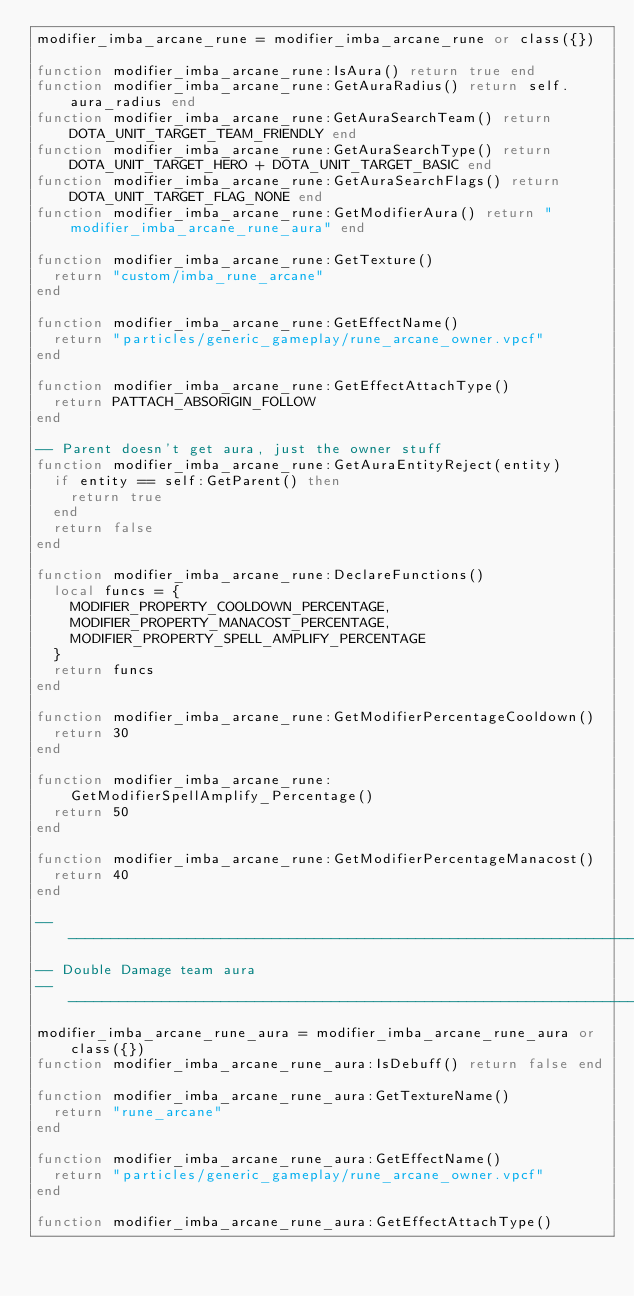<code> <loc_0><loc_0><loc_500><loc_500><_Lua_>modifier_imba_arcane_rune = modifier_imba_arcane_rune or class({})

function modifier_imba_arcane_rune:IsAura() return true end
function modifier_imba_arcane_rune:GetAuraRadius() return self.aura_radius end
function modifier_imba_arcane_rune:GetAuraSearchTeam() return DOTA_UNIT_TARGET_TEAM_FRIENDLY end
function modifier_imba_arcane_rune:GetAuraSearchType() return DOTA_UNIT_TARGET_HERO + DOTA_UNIT_TARGET_BASIC end
function modifier_imba_arcane_rune:GetAuraSearchFlags() return DOTA_UNIT_TARGET_FLAG_NONE end
function modifier_imba_arcane_rune:GetModifierAura() return "modifier_imba_arcane_rune_aura" end

function modifier_imba_arcane_rune:GetTexture()
	return "custom/imba_rune_arcane"
end

function modifier_imba_arcane_rune:GetEffectName()
	return "particles/generic_gameplay/rune_arcane_owner.vpcf"
end

function modifier_imba_arcane_rune:GetEffectAttachType()
	return PATTACH_ABSORIGIN_FOLLOW
end

-- Parent doesn't get aura, just the owner stuff
function modifier_imba_arcane_rune:GetAuraEntityReject(entity)
	if entity == self:GetParent() then
		return true
	end
	return false
end

function modifier_imba_arcane_rune:DeclareFunctions()
	local funcs = {
		MODIFIER_PROPERTY_COOLDOWN_PERCENTAGE,
		MODIFIER_PROPERTY_MANACOST_PERCENTAGE,
		MODIFIER_PROPERTY_SPELL_AMPLIFY_PERCENTAGE
	}
	return funcs
end

function modifier_imba_arcane_rune:GetModifierPercentageCooldown()
	return 30
end

function modifier_imba_arcane_rune:GetModifierSpellAmplify_Percentage()
	return 50
end

function modifier_imba_arcane_rune:GetModifierPercentageManacost()
	return 40
end

----------------------------------------------------------------------
-- Double Damage team aura
----------------------------------------------------------------------
modifier_imba_arcane_rune_aura = modifier_imba_arcane_rune_aura or class({})
function modifier_imba_arcane_rune_aura:IsDebuff() return false end

function modifier_imba_arcane_rune_aura:GetTextureName()
	return "rune_arcane"
end

function modifier_imba_arcane_rune_aura:GetEffectName()
	return "particles/generic_gameplay/rune_arcane_owner.vpcf"
end

function modifier_imba_arcane_rune_aura:GetEffectAttachType()</code> 